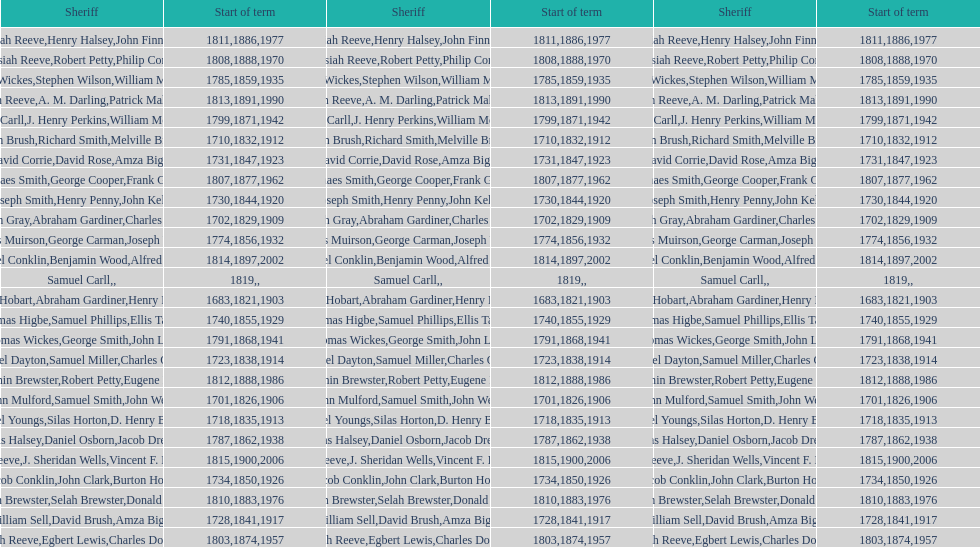When did the first sheriff's term start? 1683. 